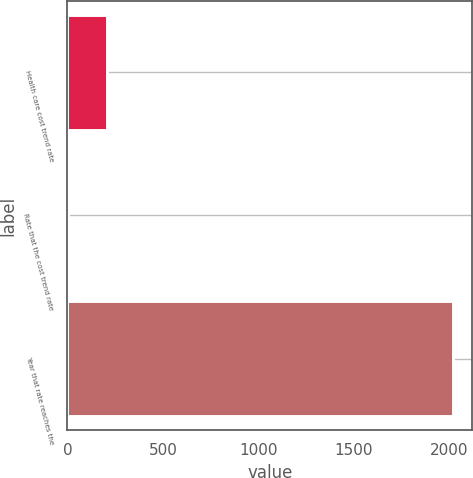Convert chart. <chart><loc_0><loc_0><loc_500><loc_500><bar_chart><fcel>Health care cost trend rate<fcel>Rate that the cost trend rate<fcel>Year that rate reaches the<nl><fcel>206.4<fcel>5<fcel>2019<nl></chart> 